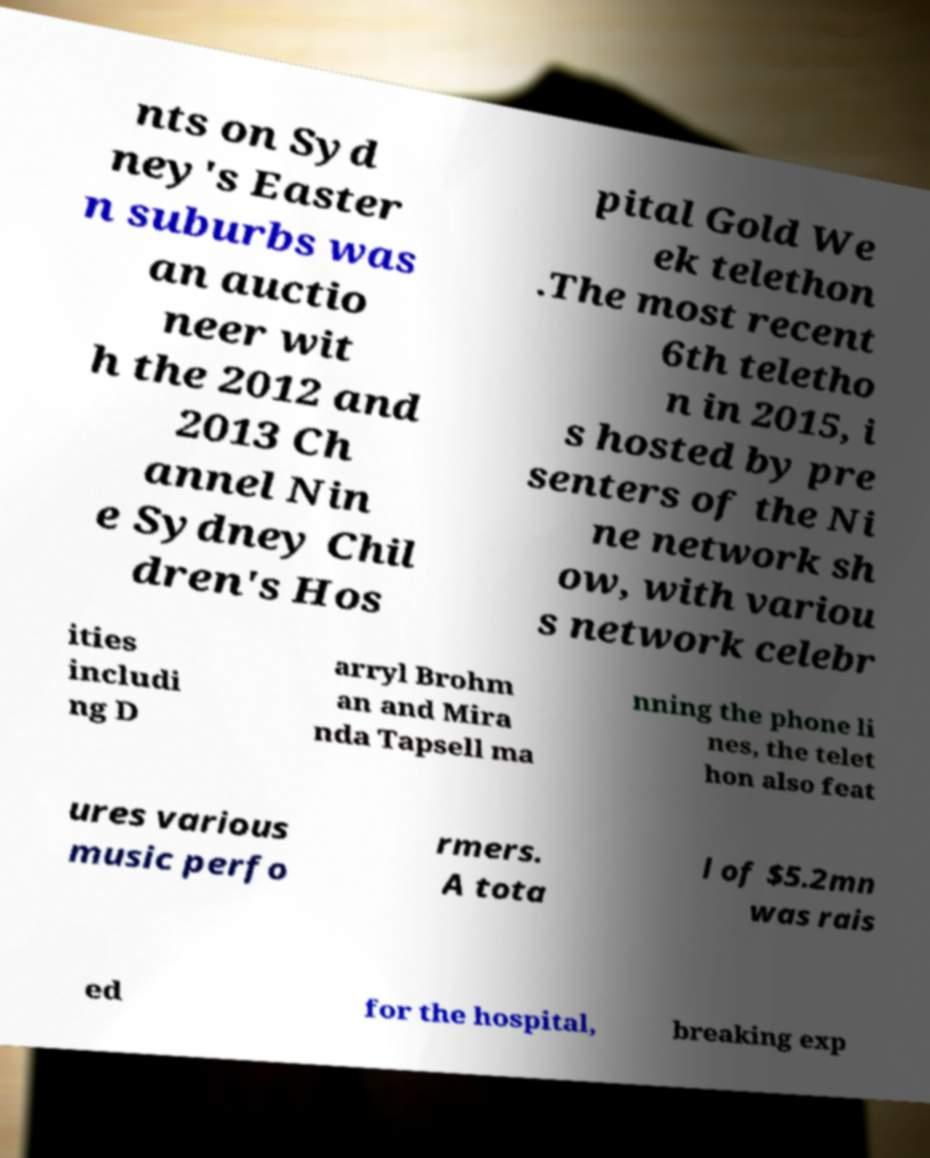I need the written content from this picture converted into text. Can you do that? nts on Syd ney's Easter n suburbs was an auctio neer wit h the 2012 and 2013 Ch annel Nin e Sydney Chil dren's Hos pital Gold We ek telethon .The most recent 6th teletho n in 2015, i s hosted by pre senters of the Ni ne network sh ow, with variou s network celebr ities includi ng D arryl Brohm an and Mira nda Tapsell ma nning the phone li nes, the telet hon also feat ures various music perfo rmers. A tota l of $5.2mn was rais ed for the hospital, breaking exp 